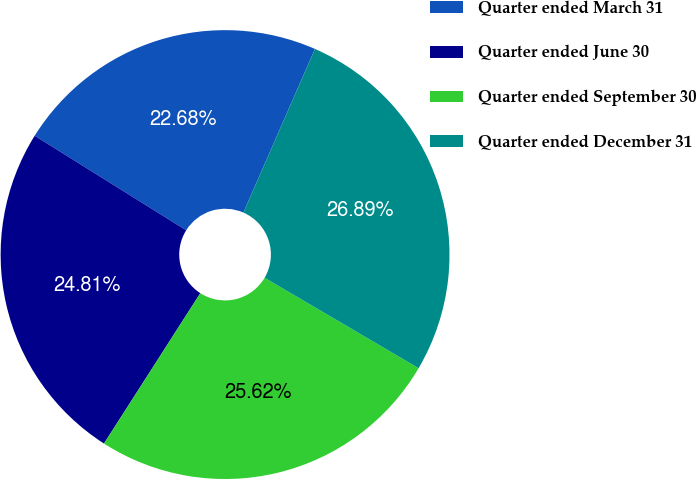Convert chart to OTSL. <chart><loc_0><loc_0><loc_500><loc_500><pie_chart><fcel>Quarter ended March 31<fcel>Quarter ended June 30<fcel>Quarter ended September 30<fcel>Quarter ended December 31<nl><fcel>22.68%<fcel>24.81%<fcel>25.62%<fcel>26.89%<nl></chart> 